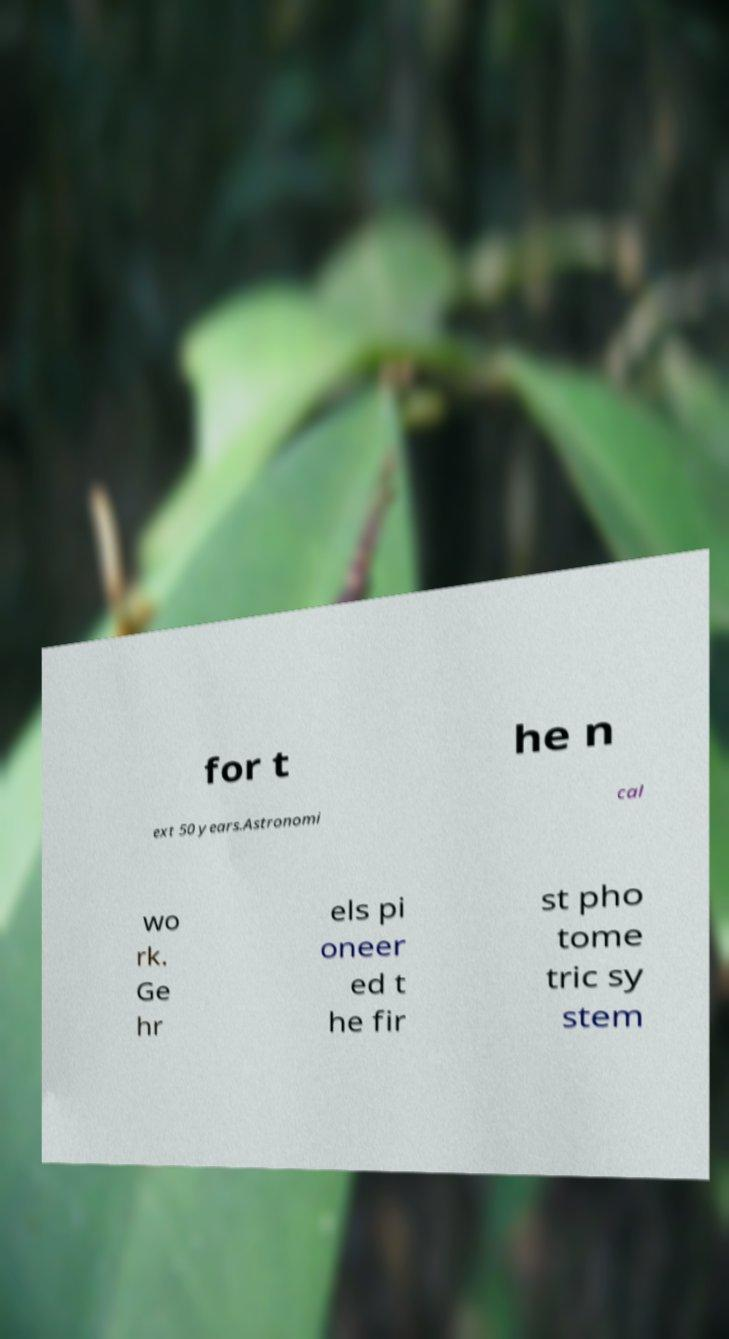What messages or text are displayed in this image? I need them in a readable, typed format. for t he n ext 50 years.Astronomi cal wo rk. Ge hr els pi oneer ed t he fir st pho tome tric sy stem 